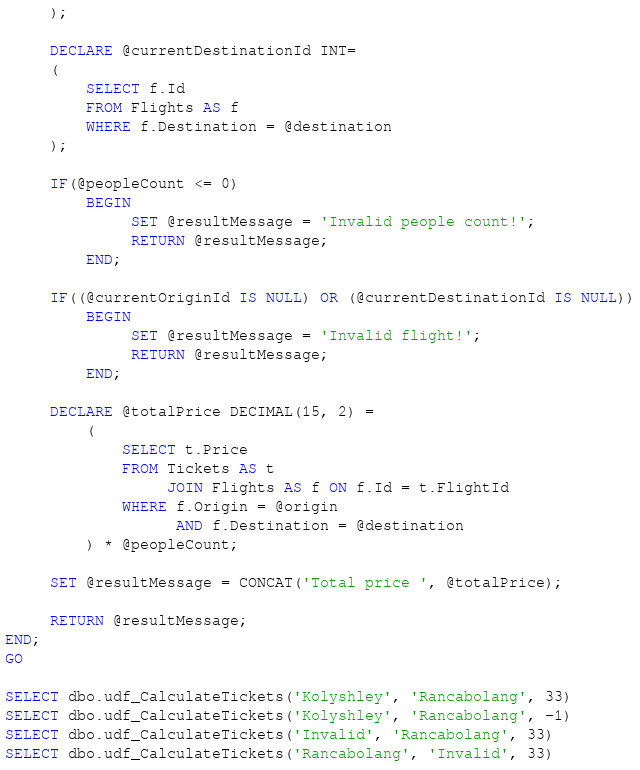Convert code to text. <code><loc_0><loc_0><loc_500><loc_500><_SQL_>     );

     DECLARE @currentDestinationId INT=
     (
         SELECT f.Id
         FROM Flights AS f
         WHERE f.Destination = @destination
     );

     IF(@peopleCount <= 0)
         BEGIN
              SET @resultMessage = 'Invalid people count!';
              RETURN @resultMessage;
         END;

     IF((@currentOriginId IS NULL) OR (@currentDestinationId IS NULL))
         BEGIN
              SET @resultMessage = 'Invalid flight!';
              RETURN @resultMessage;
         END;

     DECLARE @totalPrice DECIMAL(15, 2) =
         (
             SELECT t.Price
             FROM Tickets AS t
                  JOIN Flights AS f ON f.Id = t.FlightId
             WHERE f.Origin = @origin
                   AND f.Destination = @destination
         ) * @peopleCount;

     SET @resultMessage = CONCAT('Total price ', @totalPrice);

     RETURN @resultMessage;
END;
GO

SELECT dbo.udf_CalculateTickets('Kolyshley', 'Rancabolang', 33)
SELECT dbo.udf_CalculateTickets('Kolyshley', 'Rancabolang', -1)
SELECT dbo.udf_CalculateTickets('Invalid', 'Rancabolang', 33)
SELECT dbo.udf_CalculateTickets('Rancabolang', 'Invalid', 33)</code> 